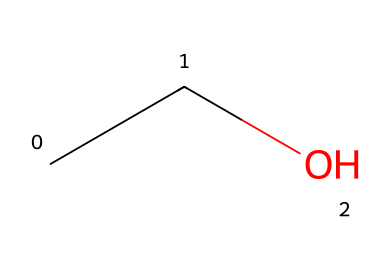What is the name of this chemical? The SMILES representation "CCO" corresponds to ethanol, which is a common alcoholic beverage component.
Answer: ethanol How many carbon atoms are in this structure? The SMILES "CCO" shows two carbon atoms (C), as each "C" represents a carbon.
Answer: 2 What is the primary functional group in ethanol? Looking at the structure, ethanol has a hydroxyl (-OH) functional group attached to one of its carbon atoms, which defines its alcohol nature.
Answer: hydroxyl What type of bond connects the carbon atoms? The two carbon atoms in "CC" are connected by a single bond, which is typical in aliphatic alcohols like ethanol.
Answer: single bond Is ethanol flammable? Ethanol is categorized as a flammable liquid, which means it can catch fire easily under certain conditions.
Answer: yes How many hydrogen atoms are attached to this molecule? In the structure "CCO," each carbon (2) bonds to hydrogen atoms to complete its four bonds; thus, ethanol has a total of 6 hydrogen atoms (3 on each carbon minus the one bonded to the hydroxyl group).
Answer: 6 What is the boiling point range of ethanol? Ethanol typically has a boiling point of around 78.37 degrees Celsius, which is a key property of flammable liquids.
Answer: 78.37 degrees Celsius 